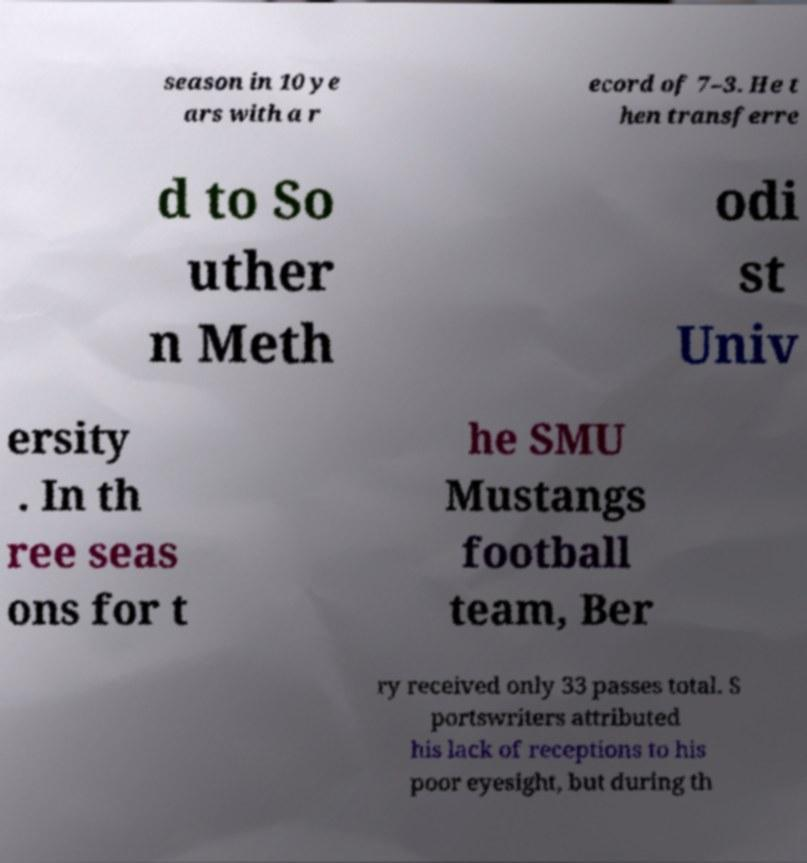I need the written content from this picture converted into text. Can you do that? season in 10 ye ars with a r ecord of 7–3. He t hen transferre d to So uther n Meth odi st Univ ersity . In th ree seas ons for t he SMU Mustangs football team, Ber ry received only 33 passes total. S portswriters attributed his lack of receptions to his poor eyesight, but during th 